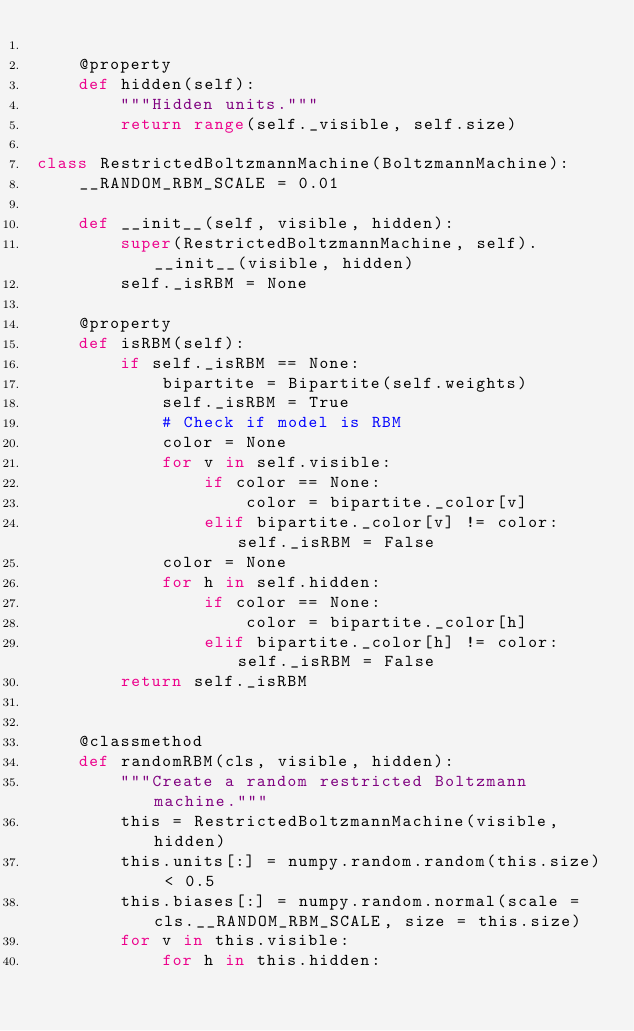Convert code to text. <code><loc_0><loc_0><loc_500><loc_500><_Python_>    
    @property
    def hidden(self):
        """Hidden units."""
        return range(self._visible, self.size)

class RestrictedBoltzmannMachine(BoltzmannMachine):
    __RANDOM_RBM_SCALE = 0.01
    
    def __init__(self, visible, hidden):
        super(RestrictedBoltzmannMachine, self).__init__(visible, hidden)
        self._isRBM = None
    
    @property
    def isRBM(self):
        if self._isRBM == None:
            bipartite = Bipartite(self.weights)
            self._isRBM = True
            # Check if model is RBM
            color = None
            for v in self.visible:
                if color == None:
                    color = bipartite._color[v]
                elif bipartite._color[v] != color: self._isRBM = False
            color = None
            for h in self.hidden:
                if color == None:
                    color = bipartite._color[h]
                elif bipartite._color[h] != color: self._isRBM = False
        return self._isRBM
    
    
    @classmethod
    def randomRBM(cls, visible, hidden):
        """Create a random restricted Boltzmann machine."""
        this = RestrictedBoltzmannMachine(visible, hidden)
        this.units[:] = numpy.random.random(this.size) < 0.5
        this.biases[:] = numpy.random.normal(scale = cls.__RANDOM_RBM_SCALE, size = this.size)
        for v in this.visible:
            for h in this.hidden:</code> 